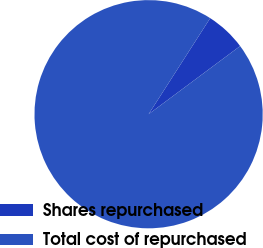Convert chart. <chart><loc_0><loc_0><loc_500><loc_500><pie_chart><fcel>Shares repurchased<fcel>Total cost of repurchased<nl><fcel>5.74%<fcel>94.26%<nl></chart> 